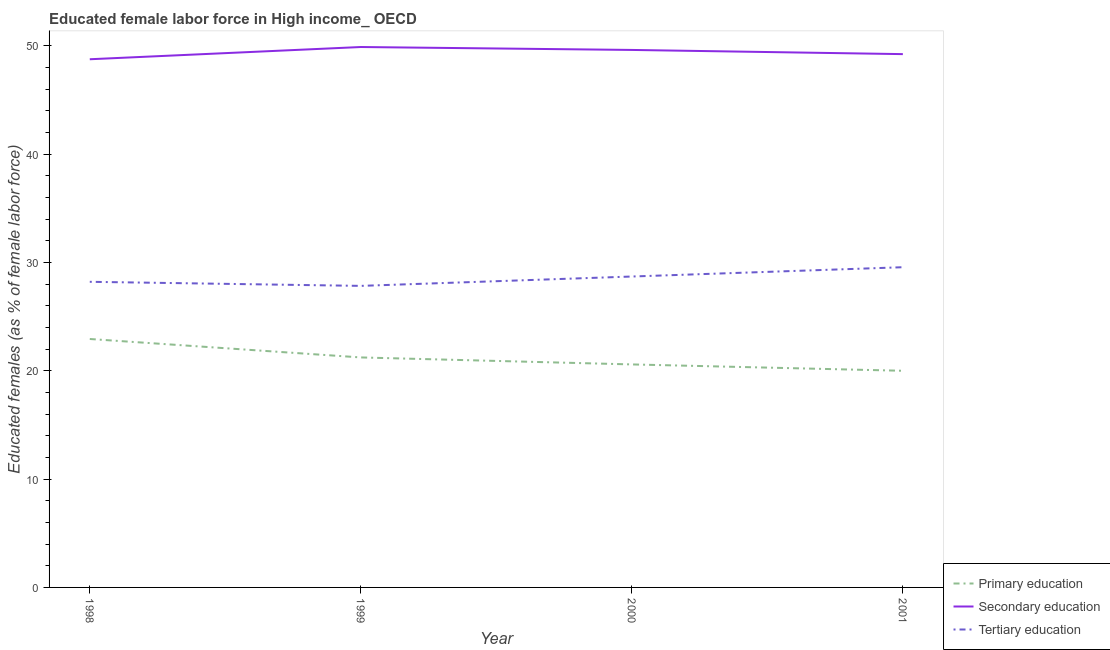How many different coloured lines are there?
Offer a very short reply. 3. What is the percentage of female labor force who received secondary education in 1998?
Offer a very short reply. 48.76. Across all years, what is the maximum percentage of female labor force who received primary education?
Provide a short and direct response. 22.94. Across all years, what is the minimum percentage of female labor force who received tertiary education?
Make the answer very short. 27.84. In which year was the percentage of female labor force who received secondary education maximum?
Provide a short and direct response. 1999. What is the total percentage of female labor force who received tertiary education in the graph?
Provide a short and direct response. 114.32. What is the difference between the percentage of female labor force who received primary education in 1999 and that in 2001?
Your answer should be compact. 1.23. What is the difference between the percentage of female labor force who received tertiary education in 1999 and the percentage of female labor force who received secondary education in 2001?
Your answer should be compact. -21.4. What is the average percentage of female labor force who received secondary education per year?
Offer a very short reply. 49.38. In the year 2000, what is the difference between the percentage of female labor force who received secondary education and percentage of female labor force who received tertiary education?
Keep it short and to the point. 20.92. What is the ratio of the percentage of female labor force who received secondary education in 1999 to that in 2001?
Keep it short and to the point. 1.01. Is the percentage of female labor force who received primary education in 1999 less than that in 2000?
Your answer should be very brief. No. Is the difference between the percentage of female labor force who received tertiary education in 1999 and 2001 greater than the difference between the percentage of female labor force who received secondary education in 1999 and 2001?
Ensure brevity in your answer.  No. What is the difference between the highest and the second highest percentage of female labor force who received secondary education?
Provide a short and direct response. 0.27. What is the difference between the highest and the lowest percentage of female labor force who received primary education?
Provide a short and direct response. 2.93. Is it the case that in every year, the sum of the percentage of female labor force who received primary education and percentage of female labor force who received secondary education is greater than the percentage of female labor force who received tertiary education?
Make the answer very short. Yes. Does the percentage of female labor force who received tertiary education monotonically increase over the years?
Give a very brief answer. No. How many lines are there?
Provide a short and direct response. 3. How many years are there in the graph?
Make the answer very short. 4. Are the values on the major ticks of Y-axis written in scientific E-notation?
Your answer should be very brief. No. Does the graph contain any zero values?
Make the answer very short. No. Where does the legend appear in the graph?
Offer a terse response. Bottom right. What is the title of the graph?
Your response must be concise. Educated female labor force in High income_ OECD. What is the label or title of the X-axis?
Provide a short and direct response. Year. What is the label or title of the Y-axis?
Offer a terse response. Educated females (as % of female labor force). What is the Educated females (as % of female labor force) in Primary education in 1998?
Your response must be concise. 22.94. What is the Educated females (as % of female labor force) of Secondary education in 1998?
Your response must be concise. 48.76. What is the Educated females (as % of female labor force) in Tertiary education in 1998?
Your response must be concise. 28.22. What is the Educated females (as % of female labor force) of Primary education in 1999?
Provide a short and direct response. 21.23. What is the Educated females (as % of female labor force) of Secondary education in 1999?
Offer a terse response. 49.89. What is the Educated females (as % of female labor force) of Tertiary education in 1999?
Offer a very short reply. 27.84. What is the Educated females (as % of female labor force) in Primary education in 2000?
Make the answer very short. 20.59. What is the Educated females (as % of female labor force) of Secondary education in 2000?
Your answer should be very brief. 49.62. What is the Educated females (as % of female labor force) in Tertiary education in 2000?
Provide a short and direct response. 28.7. What is the Educated females (as % of female labor force) of Primary education in 2001?
Provide a short and direct response. 20. What is the Educated females (as % of female labor force) of Secondary education in 2001?
Give a very brief answer. 49.23. What is the Educated females (as % of female labor force) in Tertiary education in 2001?
Offer a very short reply. 29.56. Across all years, what is the maximum Educated females (as % of female labor force) of Primary education?
Keep it short and to the point. 22.94. Across all years, what is the maximum Educated females (as % of female labor force) in Secondary education?
Make the answer very short. 49.89. Across all years, what is the maximum Educated females (as % of female labor force) of Tertiary education?
Your answer should be compact. 29.56. Across all years, what is the minimum Educated females (as % of female labor force) of Primary education?
Offer a very short reply. 20. Across all years, what is the minimum Educated females (as % of female labor force) of Secondary education?
Your response must be concise. 48.76. Across all years, what is the minimum Educated females (as % of female labor force) in Tertiary education?
Offer a very short reply. 27.84. What is the total Educated females (as % of female labor force) of Primary education in the graph?
Make the answer very short. 84.76. What is the total Educated females (as % of female labor force) in Secondary education in the graph?
Keep it short and to the point. 197.51. What is the total Educated females (as % of female labor force) in Tertiary education in the graph?
Provide a short and direct response. 114.32. What is the difference between the Educated females (as % of female labor force) in Primary education in 1998 and that in 1999?
Your answer should be compact. 1.7. What is the difference between the Educated females (as % of female labor force) in Secondary education in 1998 and that in 1999?
Ensure brevity in your answer.  -1.13. What is the difference between the Educated females (as % of female labor force) of Tertiary education in 1998 and that in 1999?
Your answer should be compact. 0.38. What is the difference between the Educated females (as % of female labor force) of Primary education in 1998 and that in 2000?
Keep it short and to the point. 2.35. What is the difference between the Educated females (as % of female labor force) of Secondary education in 1998 and that in 2000?
Offer a terse response. -0.86. What is the difference between the Educated females (as % of female labor force) of Tertiary education in 1998 and that in 2000?
Offer a terse response. -0.49. What is the difference between the Educated females (as % of female labor force) in Primary education in 1998 and that in 2001?
Your response must be concise. 2.93. What is the difference between the Educated females (as % of female labor force) of Secondary education in 1998 and that in 2001?
Provide a succinct answer. -0.47. What is the difference between the Educated females (as % of female labor force) of Tertiary education in 1998 and that in 2001?
Make the answer very short. -1.35. What is the difference between the Educated females (as % of female labor force) of Primary education in 1999 and that in 2000?
Your response must be concise. 0.65. What is the difference between the Educated females (as % of female labor force) in Secondary education in 1999 and that in 2000?
Give a very brief answer. 0.27. What is the difference between the Educated females (as % of female labor force) of Tertiary education in 1999 and that in 2000?
Your answer should be compact. -0.86. What is the difference between the Educated females (as % of female labor force) in Primary education in 1999 and that in 2001?
Offer a very short reply. 1.23. What is the difference between the Educated females (as % of female labor force) in Secondary education in 1999 and that in 2001?
Provide a short and direct response. 0.66. What is the difference between the Educated females (as % of female labor force) in Tertiary education in 1999 and that in 2001?
Provide a short and direct response. -1.72. What is the difference between the Educated females (as % of female labor force) in Primary education in 2000 and that in 2001?
Offer a very short reply. 0.59. What is the difference between the Educated females (as % of female labor force) of Secondary education in 2000 and that in 2001?
Provide a succinct answer. 0.39. What is the difference between the Educated females (as % of female labor force) in Tertiary education in 2000 and that in 2001?
Make the answer very short. -0.86. What is the difference between the Educated females (as % of female labor force) of Primary education in 1998 and the Educated females (as % of female labor force) of Secondary education in 1999?
Provide a short and direct response. -26.96. What is the difference between the Educated females (as % of female labor force) of Primary education in 1998 and the Educated females (as % of female labor force) of Tertiary education in 1999?
Provide a short and direct response. -4.9. What is the difference between the Educated females (as % of female labor force) of Secondary education in 1998 and the Educated females (as % of female labor force) of Tertiary education in 1999?
Your answer should be very brief. 20.92. What is the difference between the Educated females (as % of female labor force) in Primary education in 1998 and the Educated females (as % of female labor force) in Secondary education in 2000?
Provide a succinct answer. -26.69. What is the difference between the Educated females (as % of female labor force) of Primary education in 1998 and the Educated females (as % of female labor force) of Tertiary education in 2000?
Give a very brief answer. -5.77. What is the difference between the Educated females (as % of female labor force) of Secondary education in 1998 and the Educated females (as % of female labor force) of Tertiary education in 2000?
Keep it short and to the point. 20.06. What is the difference between the Educated females (as % of female labor force) of Primary education in 1998 and the Educated females (as % of female labor force) of Secondary education in 2001?
Keep it short and to the point. -26.3. What is the difference between the Educated females (as % of female labor force) in Primary education in 1998 and the Educated females (as % of female labor force) in Tertiary education in 2001?
Give a very brief answer. -6.63. What is the difference between the Educated females (as % of female labor force) of Secondary education in 1998 and the Educated females (as % of female labor force) of Tertiary education in 2001?
Your answer should be very brief. 19.2. What is the difference between the Educated females (as % of female labor force) of Primary education in 1999 and the Educated females (as % of female labor force) of Secondary education in 2000?
Provide a succinct answer. -28.39. What is the difference between the Educated females (as % of female labor force) in Primary education in 1999 and the Educated females (as % of female labor force) in Tertiary education in 2000?
Provide a short and direct response. -7.47. What is the difference between the Educated females (as % of female labor force) in Secondary education in 1999 and the Educated females (as % of female labor force) in Tertiary education in 2000?
Ensure brevity in your answer.  21.19. What is the difference between the Educated females (as % of female labor force) in Primary education in 1999 and the Educated females (as % of female labor force) in Secondary education in 2001?
Keep it short and to the point. -28. What is the difference between the Educated females (as % of female labor force) of Primary education in 1999 and the Educated females (as % of female labor force) of Tertiary education in 2001?
Offer a very short reply. -8.33. What is the difference between the Educated females (as % of female labor force) of Secondary education in 1999 and the Educated females (as % of female labor force) of Tertiary education in 2001?
Give a very brief answer. 20.33. What is the difference between the Educated females (as % of female labor force) of Primary education in 2000 and the Educated females (as % of female labor force) of Secondary education in 2001?
Make the answer very short. -28.65. What is the difference between the Educated females (as % of female labor force) of Primary education in 2000 and the Educated females (as % of female labor force) of Tertiary education in 2001?
Your answer should be very brief. -8.97. What is the difference between the Educated females (as % of female labor force) in Secondary education in 2000 and the Educated females (as % of female labor force) in Tertiary education in 2001?
Offer a terse response. 20.06. What is the average Educated females (as % of female labor force) of Primary education per year?
Offer a terse response. 21.19. What is the average Educated females (as % of female labor force) in Secondary education per year?
Keep it short and to the point. 49.38. What is the average Educated females (as % of female labor force) in Tertiary education per year?
Ensure brevity in your answer.  28.58. In the year 1998, what is the difference between the Educated females (as % of female labor force) of Primary education and Educated females (as % of female labor force) of Secondary education?
Provide a short and direct response. -25.83. In the year 1998, what is the difference between the Educated females (as % of female labor force) in Primary education and Educated females (as % of female labor force) in Tertiary education?
Keep it short and to the point. -5.28. In the year 1998, what is the difference between the Educated females (as % of female labor force) of Secondary education and Educated females (as % of female labor force) of Tertiary education?
Ensure brevity in your answer.  20.55. In the year 1999, what is the difference between the Educated females (as % of female labor force) of Primary education and Educated females (as % of female labor force) of Secondary education?
Provide a succinct answer. -28.66. In the year 1999, what is the difference between the Educated females (as % of female labor force) of Primary education and Educated females (as % of female labor force) of Tertiary education?
Make the answer very short. -6.61. In the year 1999, what is the difference between the Educated females (as % of female labor force) in Secondary education and Educated females (as % of female labor force) in Tertiary education?
Give a very brief answer. 22.05. In the year 2000, what is the difference between the Educated females (as % of female labor force) of Primary education and Educated females (as % of female labor force) of Secondary education?
Offer a terse response. -29.03. In the year 2000, what is the difference between the Educated females (as % of female labor force) of Primary education and Educated females (as % of female labor force) of Tertiary education?
Keep it short and to the point. -8.12. In the year 2000, what is the difference between the Educated females (as % of female labor force) in Secondary education and Educated females (as % of female labor force) in Tertiary education?
Give a very brief answer. 20.92. In the year 2001, what is the difference between the Educated females (as % of female labor force) of Primary education and Educated females (as % of female labor force) of Secondary education?
Offer a terse response. -29.23. In the year 2001, what is the difference between the Educated females (as % of female labor force) in Primary education and Educated females (as % of female labor force) in Tertiary education?
Your answer should be very brief. -9.56. In the year 2001, what is the difference between the Educated females (as % of female labor force) in Secondary education and Educated females (as % of female labor force) in Tertiary education?
Offer a very short reply. 19.67. What is the ratio of the Educated females (as % of female labor force) of Primary education in 1998 to that in 1999?
Your answer should be very brief. 1.08. What is the ratio of the Educated females (as % of female labor force) of Secondary education in 1998 to that in 1999?
Give a very brief answer. 0.98. What is the ratio of the Educated females (as % of female labor force) in Tertiary education in 1998 to that in 1999?
Give a very brief answer. 1.01. What is the ratio of the Educated females (as % of female labor force) of Primary education in 1998 to that in 2000?
Your response must be concise. 1.11. What is the ratio of the Educated females (as % of female labor force) of Secondary education in 1998 to that in 2000?
Give a very brief answer. 0.98. What is the ratio of the Educated females (as % of female labor force) of Primary education in 1998 to that in 2001?
Make the answer very short. 1.15. What is the ratio of the Educated females (as % of female labor force) in Tertiary education in 1998 to that in 2001?
Provide a succinct answer. 0.95. What is the ratio of the Educated females (as % of female labor force) of Primary education in 1999 to that in 2000?
Give a very brief answer. 1.03. What is the ratio of the Educated females (as % of female labor force) of Secondary education in 1999 to that in 2000?
Make the answer very short. 1.01. What is the ratio of the Educated females (as % of female labor force) of Tertiary education in 1999 to that in 2000?
Your response must be concise. 0.97. What is the ratio of the Educated females (as % of female labor force) in Primary education in 1999 to that in 2001?
Provide a succinct answer. 1.06. What is the ratio of the Educated females (as % of female labor force) in Secondary education in 1999 to that in 2001?
Give a very brief answer. 1.01. What is the ratio of the Educated females (as % of female labor force) in Tertiary education in 1999 to that in 2001?
Give a very brief answer. 0.94. What is the ratio of the Educated females (as % of female labor force) in Primary education in 2000 to that in 2001?
Keep it short and to the point. 1.03. What is the ratio of the Educated females (as % of female labor force) of Secondary education in 2000 to that in 2001?
Offer a very short reply. 1.01. What is the difference between the highest and the second highest Educated females (as % of female labor force) in Primary education?
Make the answer very short. 1.7. What is the difference between the highest and the second highest Educated females (as % of female labor force) of Secondary education?
Provide a short and direct response. 0.27. What is the difference between the highest and the second highest Educated females (as % of female labor force) in Tertiary education?
Offer a very short reply. 0.86. What is the difference between the highest and the lowest Educated females (as % of female labor force) in Primary education?
Your answer should be very brief. 2.93. What is the difference between the highest and the lowest Educated females (as % of female labor force) in Secondary education?
Your answer should be compact. 1.13. What is the difference between the highest and the lowest Educated females (as % of female labor force) of Tertiary education?
Your answer should be compact. 1.72. 